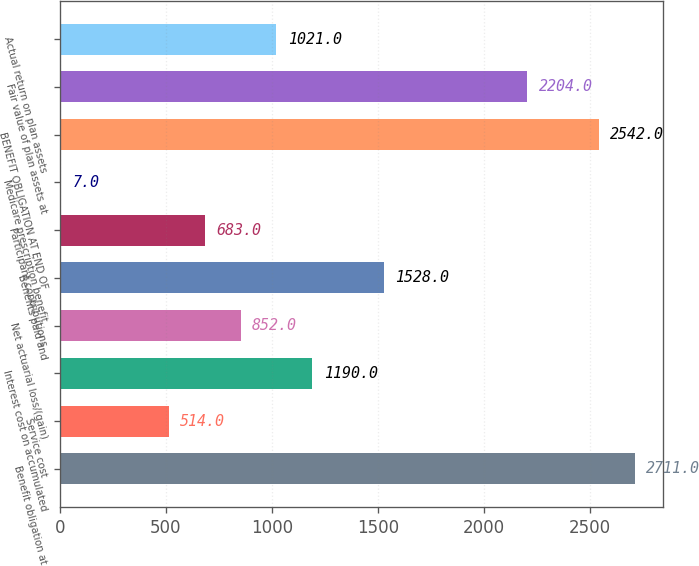<chart> <loc_0><loc_0><loc_500><loc_500><bar_chart><fcel>Benefit obligation at<fcel>Service cost<fcel>Interest cost on accumulated<fcel>Net actuarial loss/(gain)<fcel>Benefits paid and<fcel>Participant contributions<fcel>Medicare prescription benefit<fcel>BENEFIT OBLIGATION AT END OF<fcel>Fair value of plan assets at<fcel>Actual return on plan assets<nl><fcel>2711<fcel>514<fcel>1190<fcel>852<fcel>1528<fcel>683<fcel>7<fcel>2542<fcel>2204<fcel>1021<nl></chart> 